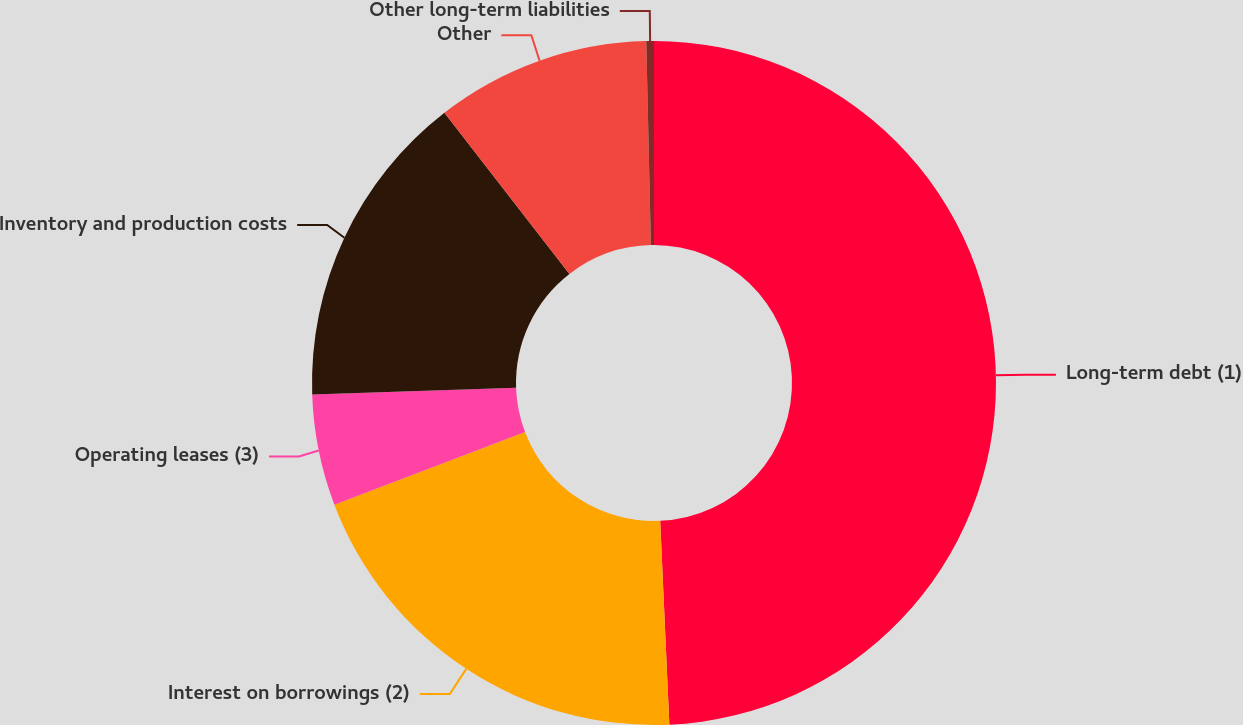Convert chart to OTSL. <chart><loc_0><loc_0><loc_500><loc_500><pie_chart><fcel>Long-term debt (1)<fcel>Interest on borrowings (2)<fcel>Operating leases (3)<fcel>Inventory and production costs<fcel>Other<fcel>Other long-term liabilities<nl><fcel>49.29%<fcel>19.93%<fcel>5.25%<fcel>15.04%<fcel>10.14%<fcel>0.36%<nl></chart> 